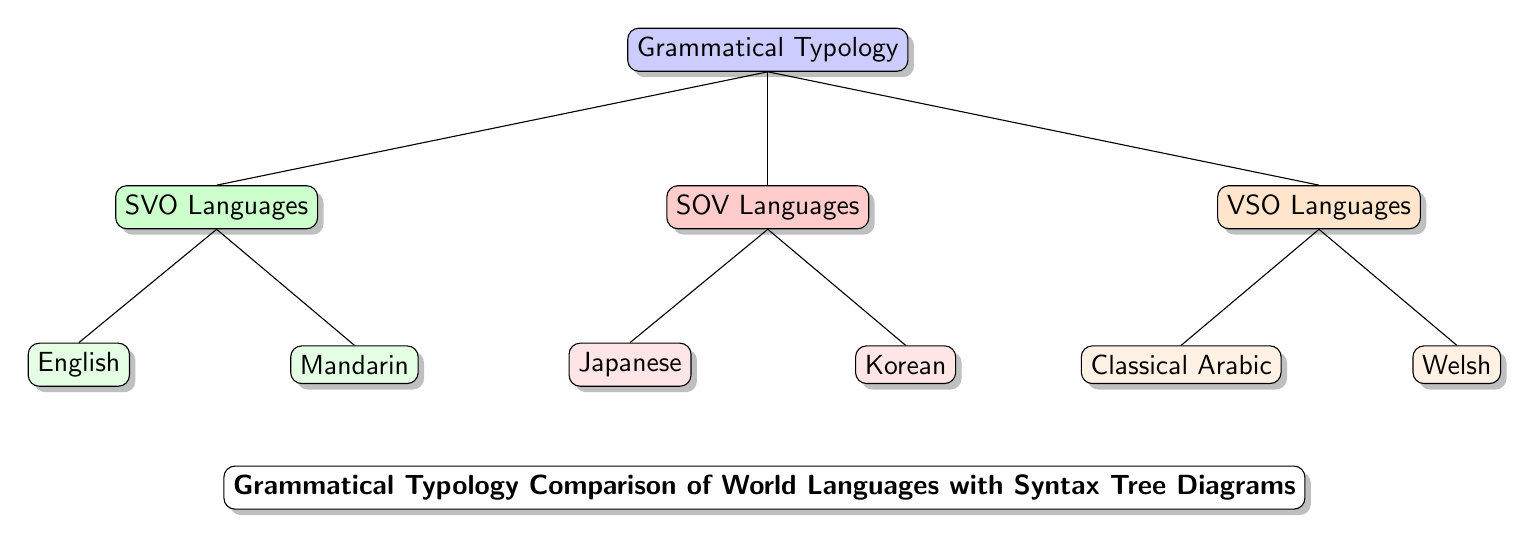What are the categories of grammatical typology shown in the diagram? The diagram presents three categories of grammatical typology: SVO Languages, SOV Languages, and VSO Languages. These are the primary branches stemming from the main node "Grammatical Typology."
Answer: SVO Languages, SOV Languages, VSO Languages How many languages are listed under SOV Languages? Under the SOV Languages category, there are two languages listed: Japanese and Korean. This can be identified by tracing the child nodes under the SOV branch.
Answer: 2 Which language is associated with the SVO category? The SVO Languages category has two example languages, and "English" is one of them. By following the path from the SVO node, we arrive at this language.
Answer: English What is the relationship between VSO and SOV Languages in the diagram? VSO and SOV Languages are sibling categories in the diagram. They share the same parent node "Grammatical Typology," indicating they are both branches of the same overarching typological classification.
Answer: Sibling categories Which language is at the bottom of the VSO branch? The language at the bottom of the VSO branch is "Welsh." It is the last child node under the VSO Languages category.
Answer: Welsh How many total languages are represented in the diagram? There are a total of six languages represented in the diagram: English, Mandarin, Japanese, Korean, Classical Arabic, and Welsh. By counting the leaves down each branch, we arrive at this total.
Answer: 6 What color is used to represent SOV Languages? The SOV Languages are represented in red, as indicated by the fill color assigned to the SOV branch in the diagram.
Answer: Red Which category contains Classical Arabic? Classical Arabic is found in the VSO Languages category. This can be verified by locating it as a child node under the VSO branch in the diagram.
Answer: VSO Languages What title does the diagram have? The title at the bottom of the diagram is "Grammatical Typology Comparison of World Languages with Syntax Tree Diagrams." This provides the overall context of the diagram's content.
Answer: Grammatical Typology Comparison of World Languages with Syntax Tree Diagrams 